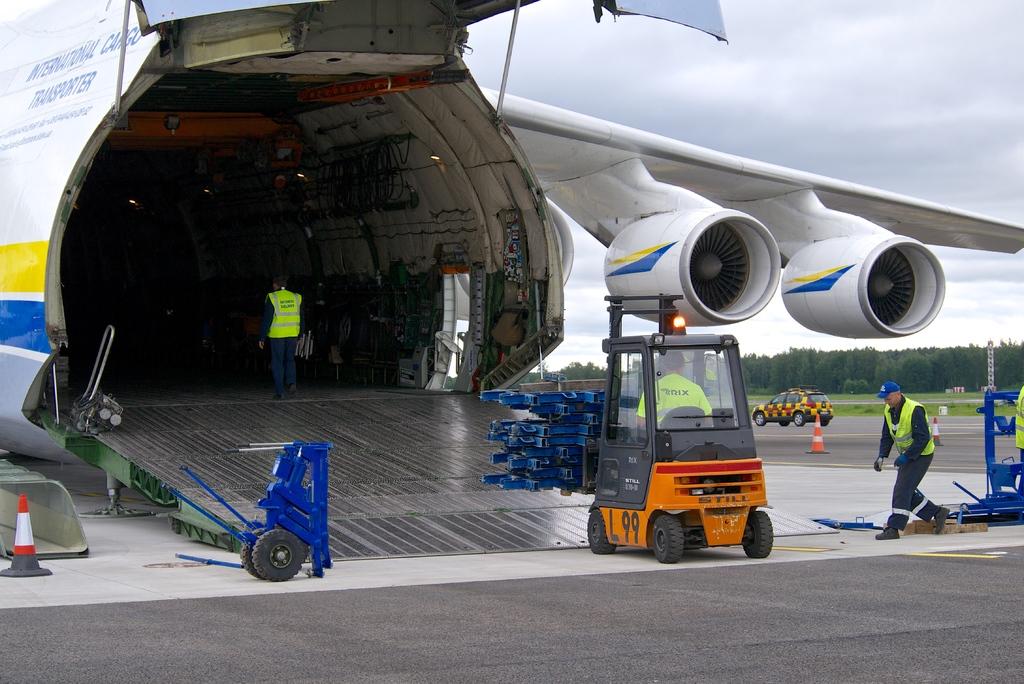What number is on the side of the orange forklift?
Offer a very short reply. 99. 